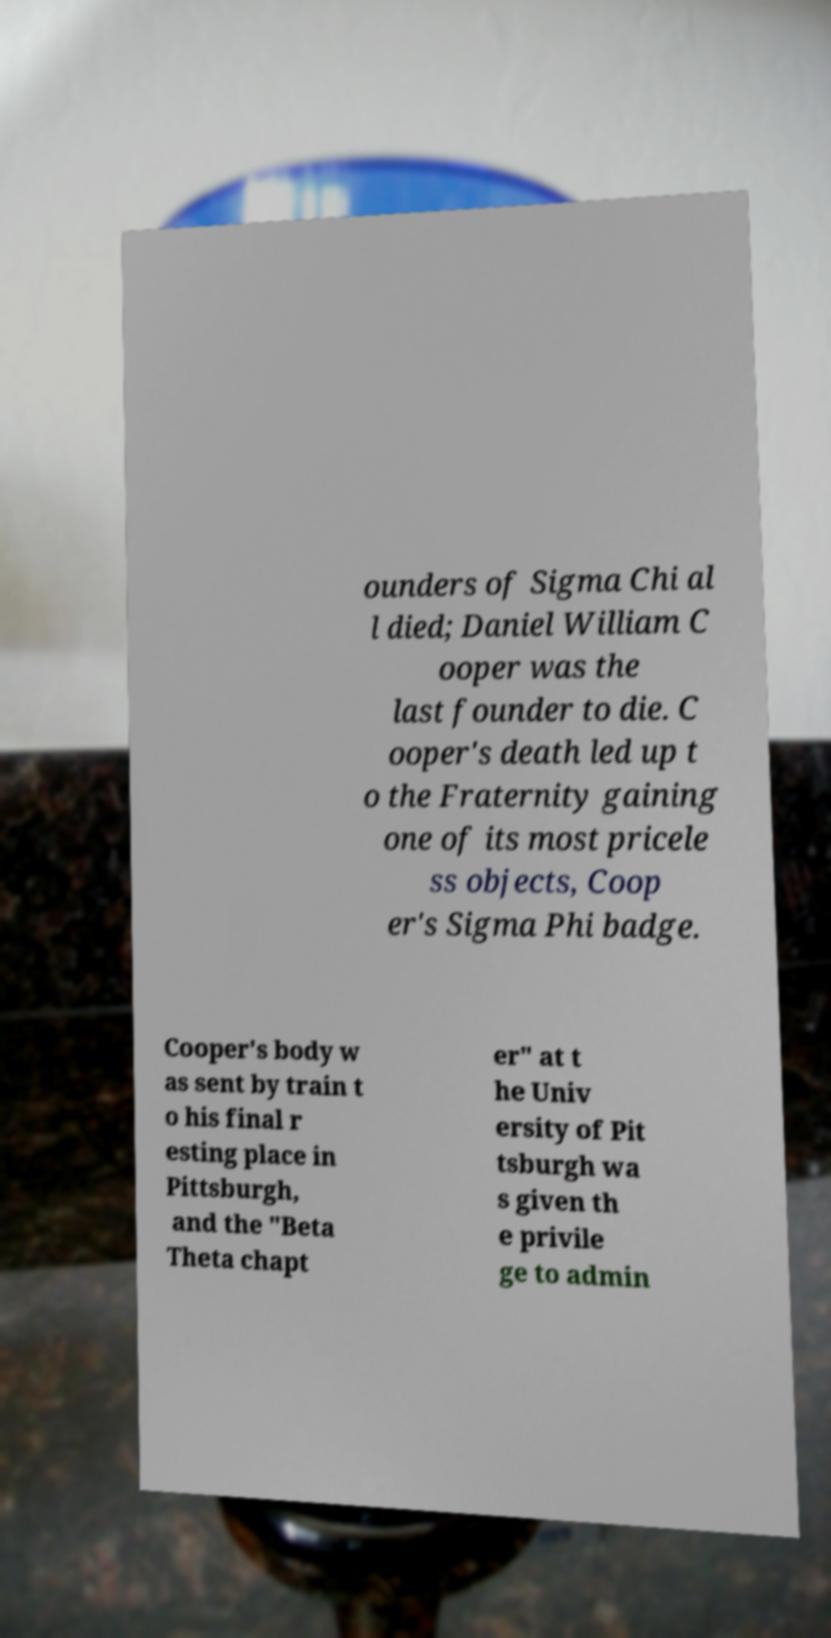There's text embedded in this image that I need extracted. Can you transcribe it verbatim? ounders of Sigma Chi al l died; Daniel William C ooper was the last founder to die. C ooper's death led up t o the Fraternity gaining one of its most pricele ss objects, Coop er's Sigma Phi badge. Cooper's body w as sent by train t o his final r esting place in Pittsburgh, and the "Beta Theta chapt er" at t he Univ ersity of Pit tsburgh wa s given th e privile ge to admin 